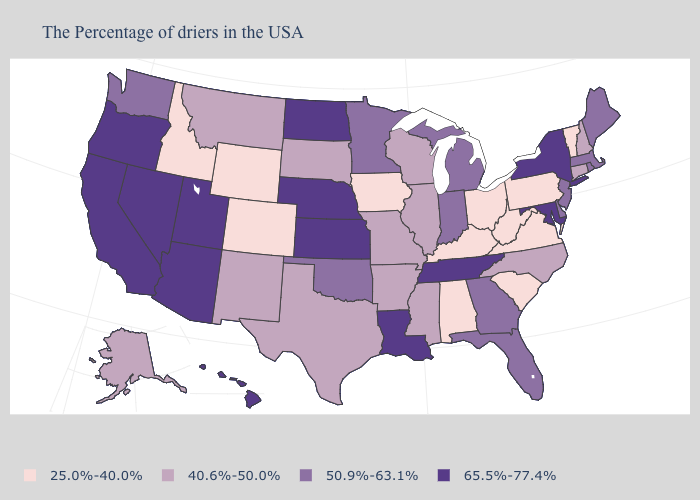Does Montana have the same value as Washington?
Give a very brief answer. No. What is the highest value in the USA?
Be succinct. 65.5%-77.4%. What is the highest value in the USA?
Concise answer only. 65.5%-77.4%. Does Ohio have the same value as Wisconsin?
Short answer required. No. Which states hav the highest value in the MidWest?
Keep it brief. Kansas, Nebraska, North Dakota. What is the highest value in the USA?
Write a very short answer. 65.5%-77.4%. Name the states that have a value in the range 40.6%-50.0%?
Be succinct. New Hampshire, Connecticut, North Carolina, Wisconsin, Illinois, Mississippi, Missouri, Arkansas, Texas, South Dakota, New Mexico, Montana, Alaska. Name the states that have a value in the range 50.9%-63.1%?
Keep it brief. Maine, Massachusetts, Rhode Island, New Jersey, Delaware, Florida, Georgia, Michigan, Indiana, Minnesota, Oklahoma, Washington. What is the highest value in the USA?
Give a very brief answer. 65.5%-77.4%. Does Virginia have the lowest value in the USA?
Quick response, please. Yes. What is the value of Virginia?
Concise answer only. 25.0%-40.0%. Which states hav the highest value in the Northeast?
Write a very short answer. New York. Does Washington have the highest value in the West?
Keep it brief. No. Name the states that have a value in the range 50.9%-63.1%?
Short answer required. Maine, Massachusetts, Rhode Island, New Jersey, Delaware, Florida, Georgia, Michigan, Indiana, Minnesota, Oklahoma, Washington. 